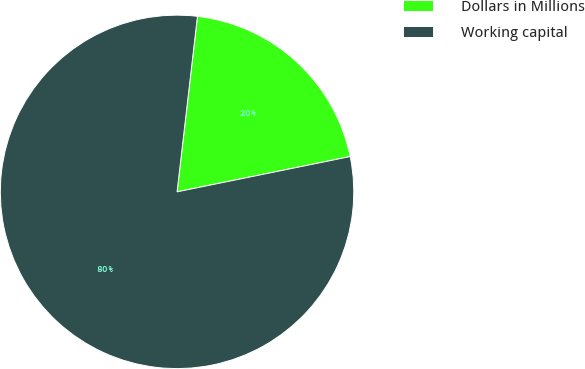Convert chart to OTSL. <chart><loc_0><loc_0><loc_500><loc_500><pie_chart><fcel>Dollars in Millions<fcel>Working capital<nl><fcel>19.96%<fcel>80.04%<nl></chart> 